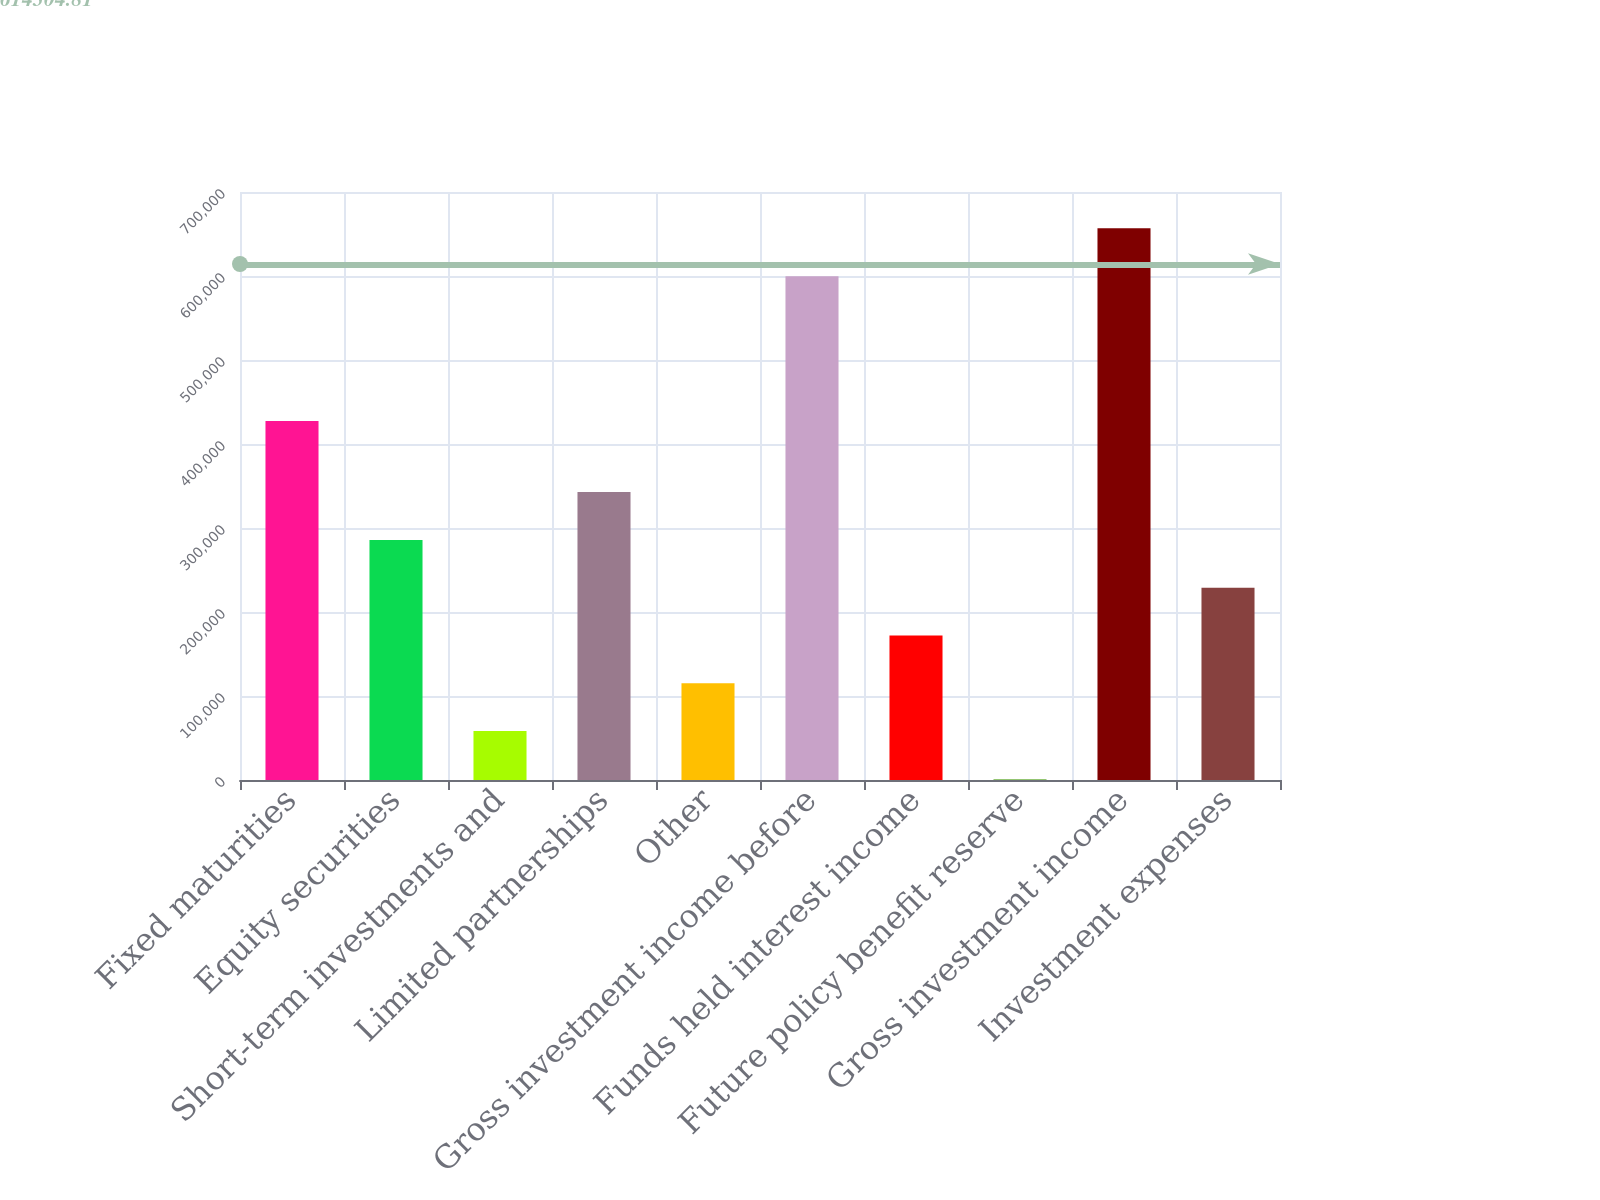<chart> <loc_0><loc_0><loc_500><loc_500><bar_chart><fcel>Fixed maturities<fcel>Equity securities<fcel>Short-term investments and<fcel>Limited partnerships<fcel>Other<fcel>Gross investment income before<fcel>Funds held interest income<fcel>Future policy benefit reserve<fcel>Gross investment income<fcel>Investment expenses<nl><fcel>427379<fcel>285824<fcel>58190.3<fcel>342732<fcel>115099<fcel>599806<fcel>172007<fcel>1282<fcel>656715<fcel>228915<nl></chart> 